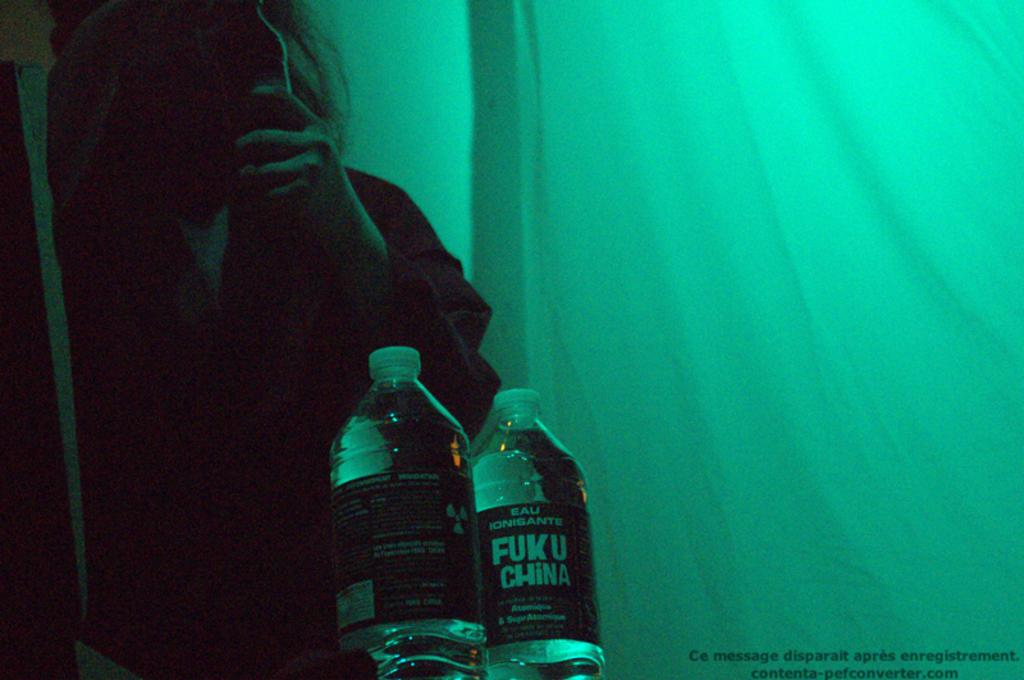<image>
Give a short and clear explanation of the subsequent image. A person holds their phone to their face in a green tent with two water bottles, one of which has a label that says FUK U CHINA. 